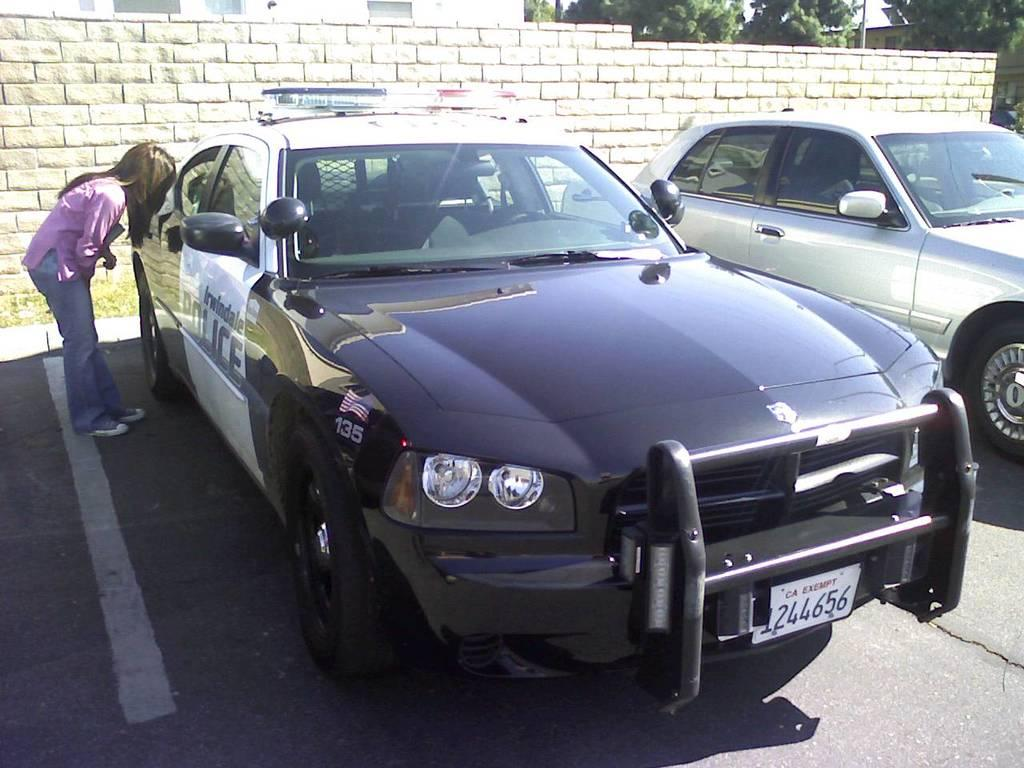What types of objects are present in the image? There are vehicles in the image. Can you describe the person in the image? There is a person standing in the image. What can be seen in the background of the image? There is a brick wall in the background of the image. What other natural elements are visible in the image? There are trees in the image. How many letters are being carried by the sheep in the image? There are no sheep present in the image, and therefore no letters being carried by them. 